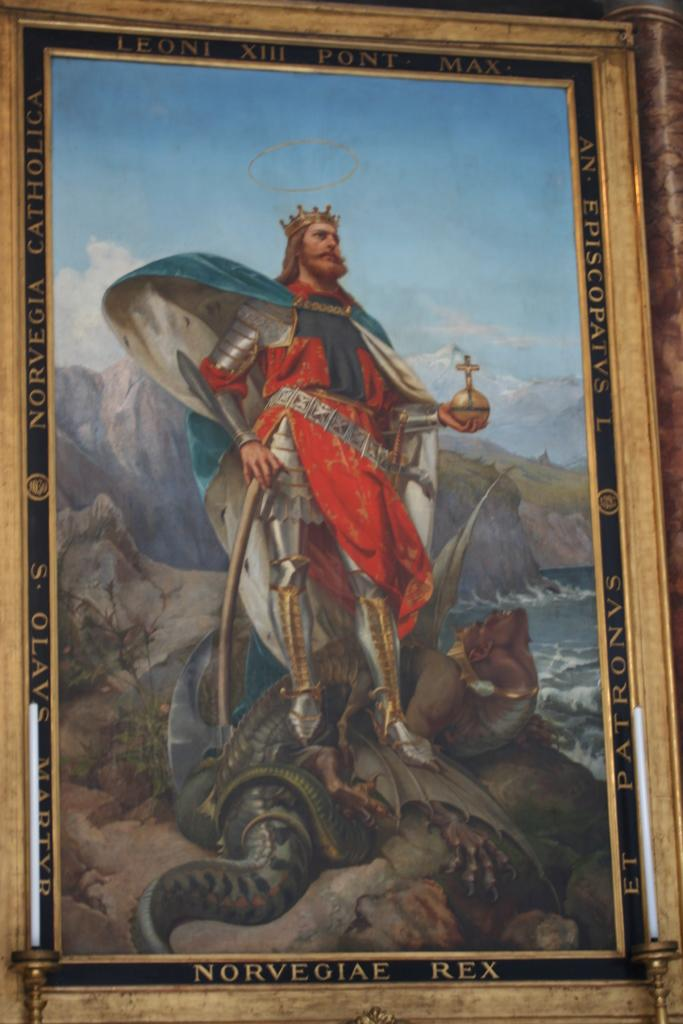<image>
Write a terse but informative summary of the picture. Norvegiae Rex stands on rocks over a monster that he defeated. 